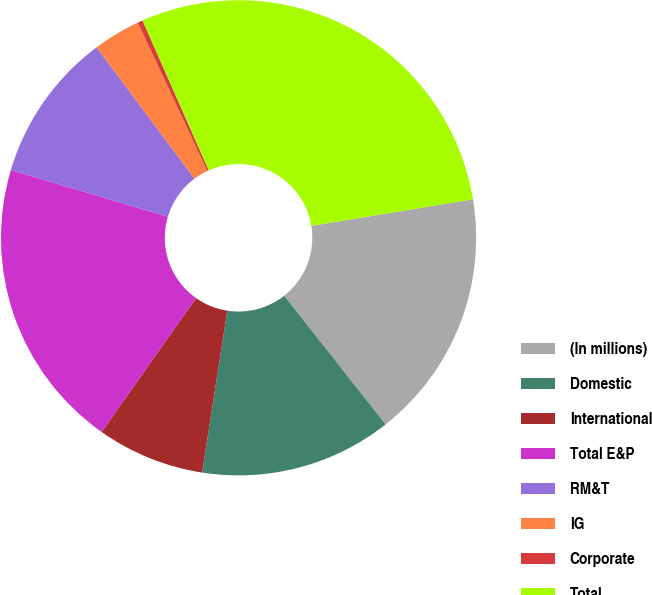Convert chart to OTSL. <chart><loc_0><loc_0><loc_500><loc_500><pie_chart><fcel>(In millions)<fcel>Domestic<fcel>International<fcel>Total E&P<fcel>RM&T<fcel>IG<fcel>Corporate<fcel>Total<nl><fcel>16.97%<fcel>13.07%<fcel>7.33%<fcel>19.83%<fcel>10.2%<fcel>3.22%<fcel>0.35%<fcel>29.03%<nl></chart> 